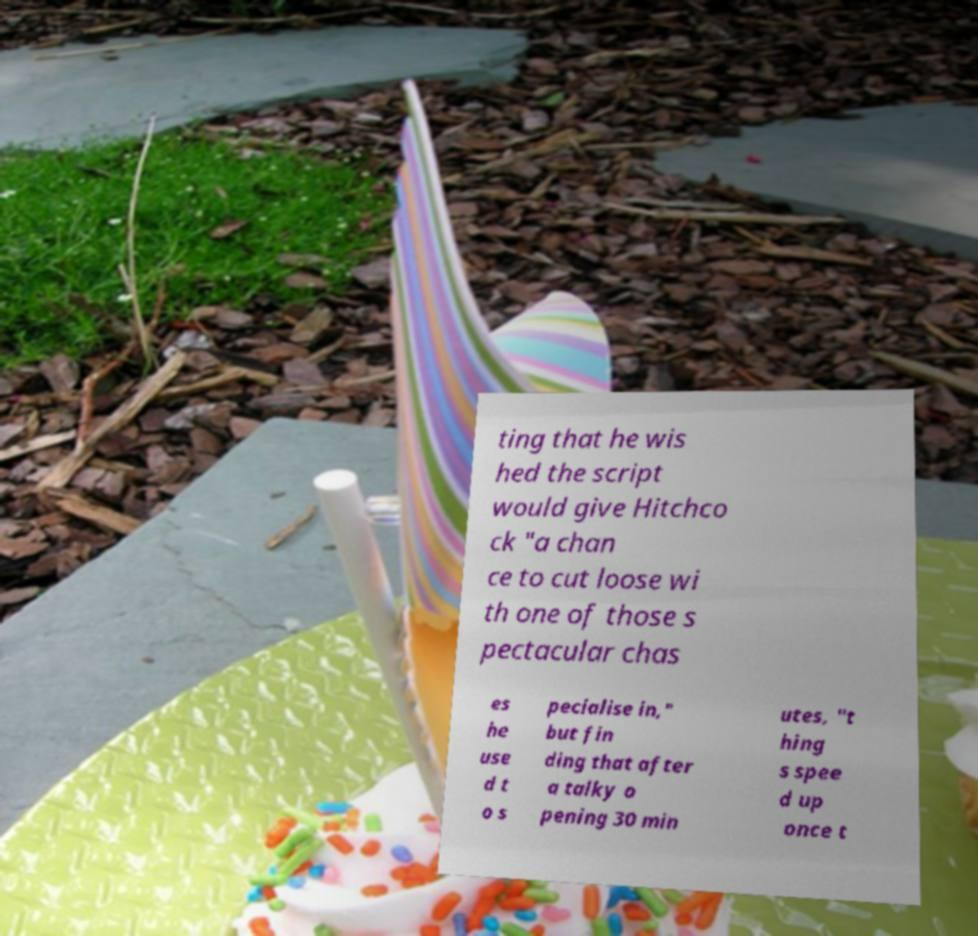What messages or text are displayed in this image? I need them in a readable, typed format. ting that he wis hed the script would give Hitchco ck "a chan ce to cut loose wi th one of those s pectacular chas es he use d t o s pecialise in," but fin ding that after a talky o pening 30 min utes, "t hing s spee d up once t 